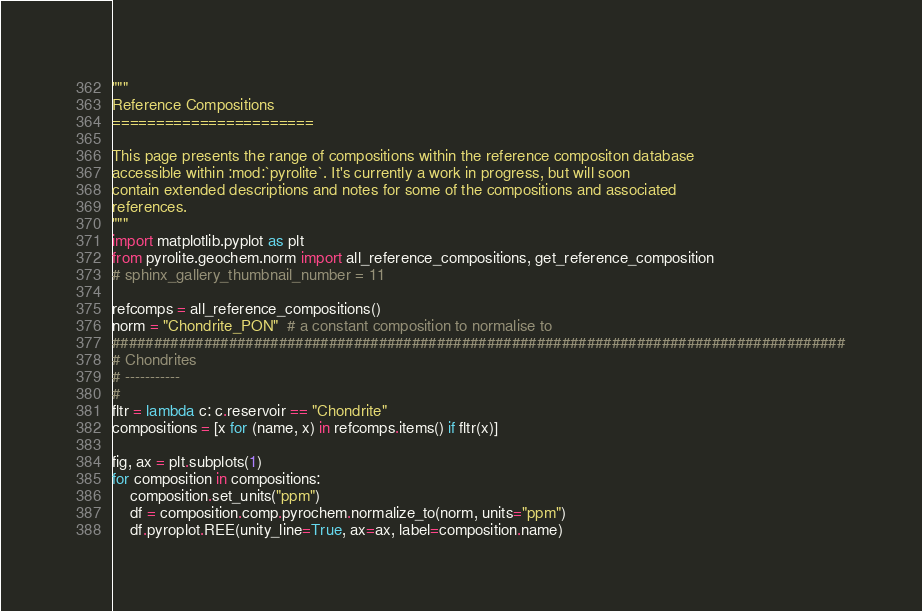Convert code to text. <code><loc_0><loc_0><loc_500><loc_500><_Python_>"""
Reference Compositions
=======================

This page presents the range of compositions within the reference compositon database
accessible within :mod:`pyrolite`. It's currently a work in progress, but will soon
contain extended descriptions and notes for some of the compositions and associated
references.
"""
import matplotlib.pyplot as plt
from pyrolite.geochem.norm import all_reference_compositions, get_reference_composition
# sphinx_gallery_thumbnail_number = 11

refcomps = all_reference_compositions()
norm = "Chondrite_PON"  # a constant composition to normalise to
########################################################################################
# Chondrites
# -----------
#
fltr = lambda c: c.reservoir == "Chondrite"
compositions = [x for (name, x) in refcomps.items() if fltr(x)]

fig, ax = plt.subplots(1)
for composition in compositions:
    composition.set_units("ppm")
    df = composition.comp.pyrochem.normalize_to(norm, units="ppm")
    df.pyroplot.REE(unity_line=True, ax=ax, label=composition.name)</code> 